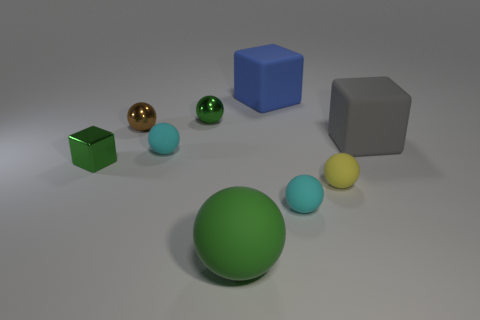What number of cyan objects are either metallic objects or tiny things?
Give a very brief answer. 2. How many other spheres are the same color as the big sphere?
Offer a very short reply. 1. Do the tiny brown object and the big ball have the same material?
Make the answer very short. No. How many rubber things are behind the block behind the gray cube?
Your answer should be very brief. 0. Do the brown metal ball and the blue matte object have the same size?
Give a very brief answer. No. What number of blue things are made of the same material as the blue block?
Give a very brief answer. 0. What is the size of the other matte thing that is the same shape as the gray matte thing?
Provide a succinct answer. Large. There is a big object to the left of the blue thing; is it the same shape as the big blue rubber thing?
Ensure brevity in your answer.  No. What shape is the small cyan rubber object to the right of the tiny cyan object that is on the left side of the large rubber sphere?
Your answer should be compact. Sphere. Are there any other things that have the same shape as the big gray object?
Offer a terse response. Yes. 